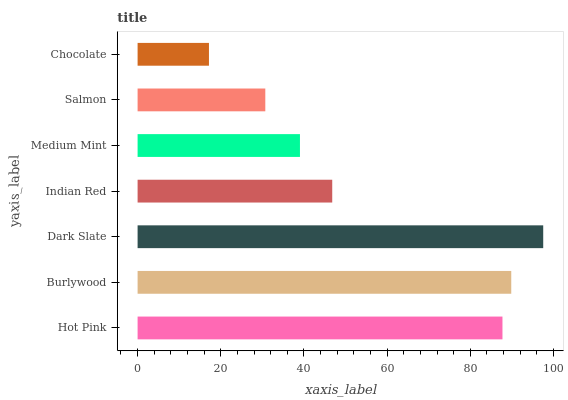Is Chocolate the minimum?
Answer yes or no. Yes. Is Dark Slate the maximum?
Answer yes or no. Yes. Is Burlywood the minimum?
Answer yes or no. No. Is Burlywood the maximum?
Answer yes or no. No. Is Burlywood greater than Hot Pink?
Answer yes or no. Yes. Is Hot Pink less than Burlywood?
Answer yes or no. Yes. Is Hot Pink greater than Burlywood?
Answer yes or no. No. Is Burlywood less than Hot Pink?
Answer yes or no. No. Is Indian Red the high median?
Answer yes or no. Yes. Is Indian Red the low median?
Answer yes or no. Yes. Is Medium Mint the high median?
Answer yes or no. No. Is Medium Mint the low median?
Answer yes or no. No. 